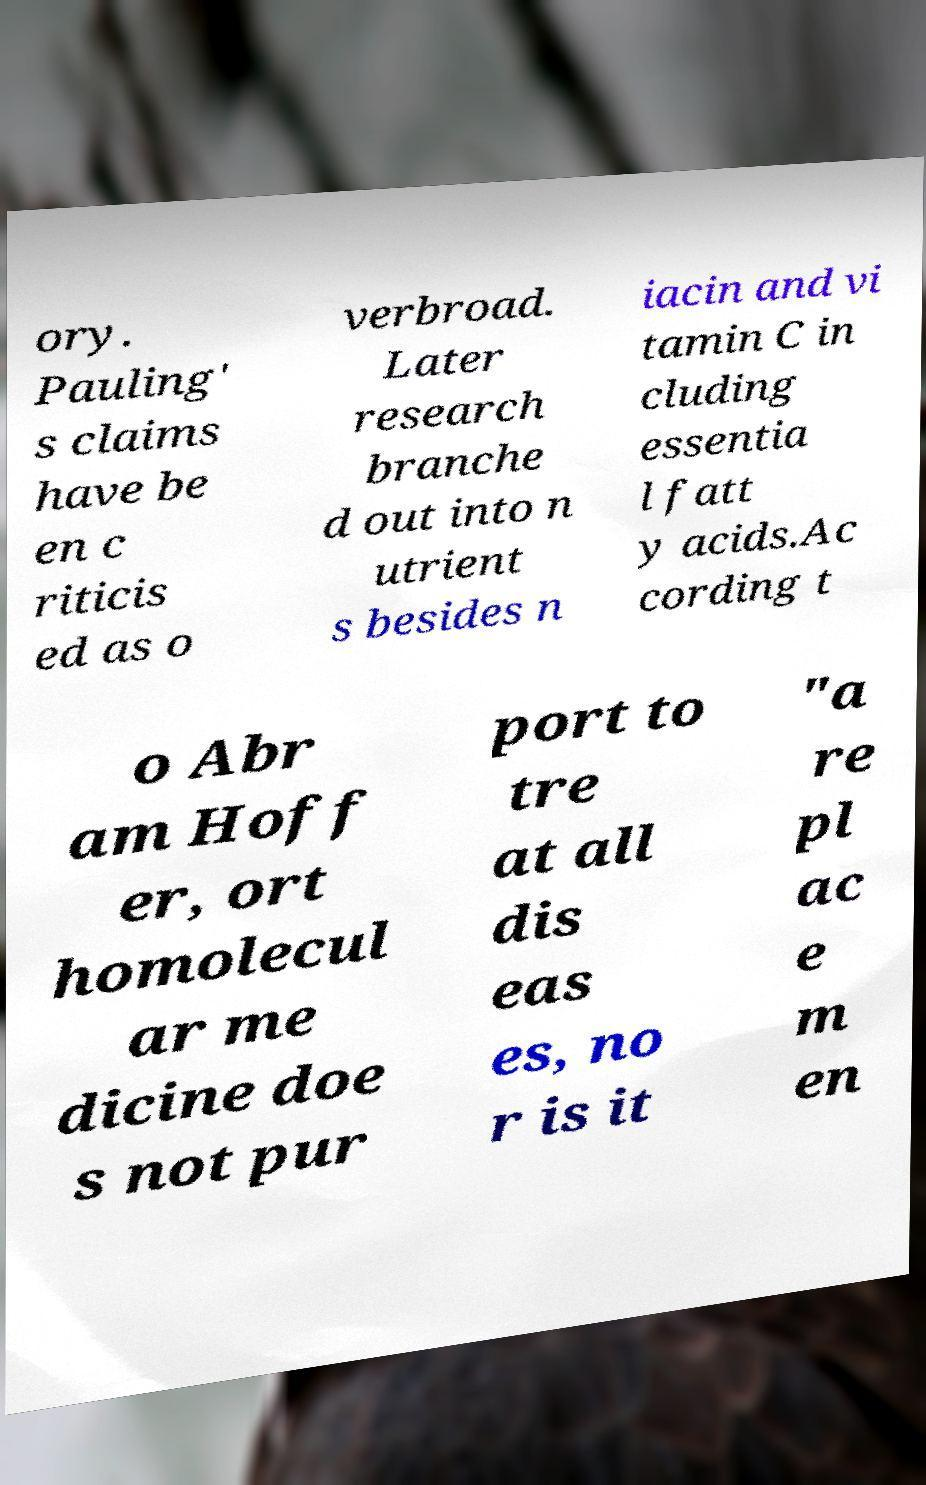Could you extract and type out the text from this image? ory. Pauling' s claims have be en c riticis ed as o verbroad. Later research branche d out into n utrient s besides n iacin and vi tamin C in cluding essentia l fatt y acids.Ac cording t o Abr am Hoff er, ort homolecul ar me dicine doe s not pur port to tre at all dis eas es, no r is it "a re pl ac e m en 